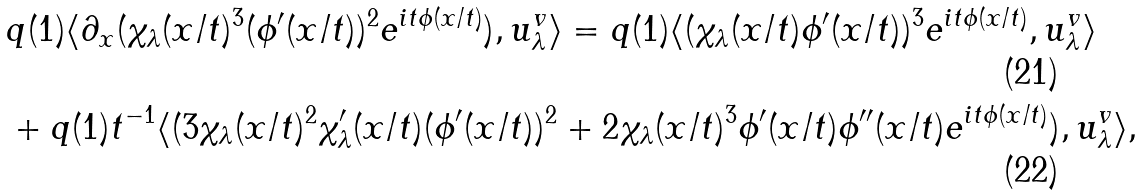<formula> <loc_0><loc_0><loc_500><loc_500>& q ( 1 ) \langle \partial _ { x } ( \chi _ { \lambda } ( x / t ) ^ { 3 } ( \phi ^ { \prime } ( x / t ) ) ^ { 2 } e ^ { i t \phi ( x / t ) } ) , u ^ { v } _ { \lambda } \rangle = q ( 1 ) \langle ( \chi _ { \lambda } ( x / t ) \phi ^ { \prime } ( x / t ) ) ^ { 3 } e ^ { i t \phi ( x / t ) } , u ^ { v } _ { \lambda } \rangle \\ & + q ( 1 ) t ^ { - 1 } \langle ( 3 \chi _ { \lambda } ( x / t ) ^ { 2 } \chi _ { \lambda } ^ { \prime } ( x / t ) ( \phi ^ { \prime } ( x / t ) ) ^ { 2 } + 2 \chi _ { \lambda } ( x / t ) ^ { 3 } \phi ^ { \prime } ( x / t ) \phi ^ { \prime \prime } ( x / t ) e ^ { i t \phi ( x / t ) } ) , u ^ { v } _ { \lambda } \rangle ,</formula> 